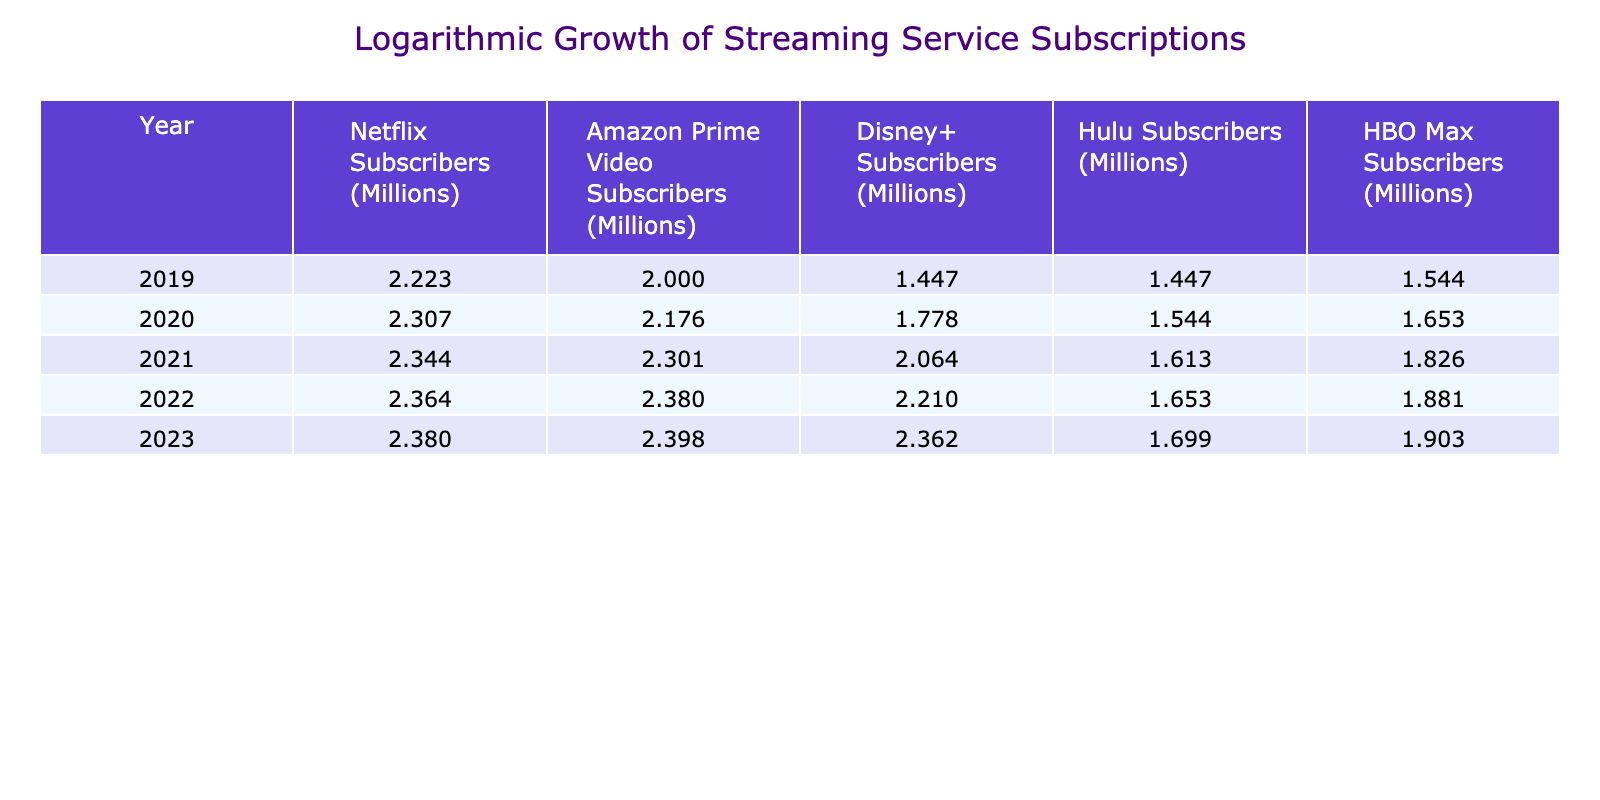What were the logarithmic subscribers for Netflix in 2022? The table shows the logarithmic value for Netflix subscribers in 2022 as approximately 2.363. This can be directly retrieved from the respective cell in the table.
Answer: 2.363 Which streaming service had the highest logarithmic subscribers in 2023? By looking at the 2023 row in the table, we see that Netflix with a value of approximately 2.380 has the highest logarithmic subscriber count compared to the other services.
Answer: Netflix What is the difference in logarithmic subscribers between Hulu and Disney+ in 2021? The logarithmic value for Hulu in 2021 is approximately 1.613, while for Disney+ it is approximately 2.064. The difference can be calculated as 2.064 - 1.613 = 0.451.
Answer: 0.451 Was there an increase in logarithmic subscribers for Amazon Prime Video from 2020 to 2021? The logarithmic value for Amazon Prime Video in 2020 is approximately 2.176, and in 2021 it is approximately 2.301. Since 2.301 is greater than 2.176, there was indeed an increase.
Answer: Yes What is the total logarithmic subscribers for all services in 2022? The logarithmic subscribers for 2022 can be summed as follows: (2.363 for Netflix) + (2.380 for Amazon Prime Video) + (2.208 for Disney+) + (1.653 for Hulu) + (1.880 for HBO Max) = 11.485. Thus, the total is approximately 11.485.
Answer: 11.485 What was the average logarithmic subscriber count for all services in 2019? The logarithmic values for 2019 are: Netflix (2.223), Amazon Prime Video (2.000), Disney+ (1.447), Hulu (1.447), and HBO Max (1.544). The sum is 2.223 + 2.000 + 1.447 + 1.447 + 1.544 = 8.711, and there are 5 services, so the average is 8.711 / 5 = 1.742.
Answer: 1.742 Did HBO Max have more logarithmic subscribers than Hulu in 2022? The logarithmic value for HBO Max in 2022 is approximately 1.880, while for Hulu it is 1.653. Since 1.880 is greater than 1.653, HBO Max indeed had more subscribers than Hulu.
Answer: Yes What was the trend of logarithmic values for Disney+ from 2019 to 2023? The logarithmic value for Disney+ increased from approximately 1.447 in 2019 to 2.363 in 2023. This indicates a consistent upward trend in subscribers over these years.
Answer: Increasing 